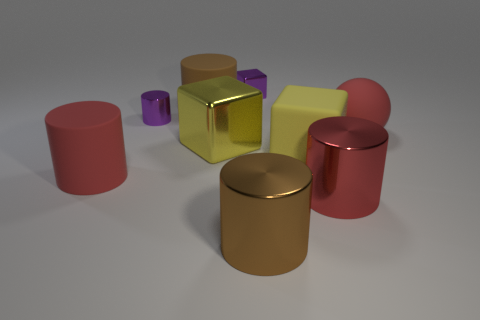Which objects in the image appear to have a reflective surface? The objects with a reflective surface in this image include the yellow cube, the silver cylindrical object, and the gold cylindrical object, as you can see light being reflected off their surfaces. 